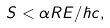Convert formula to latex. <formula><loc_0><loc_0><loc_500><loc_500>S < \alpha R E / \hbar { c } ,</formula> 